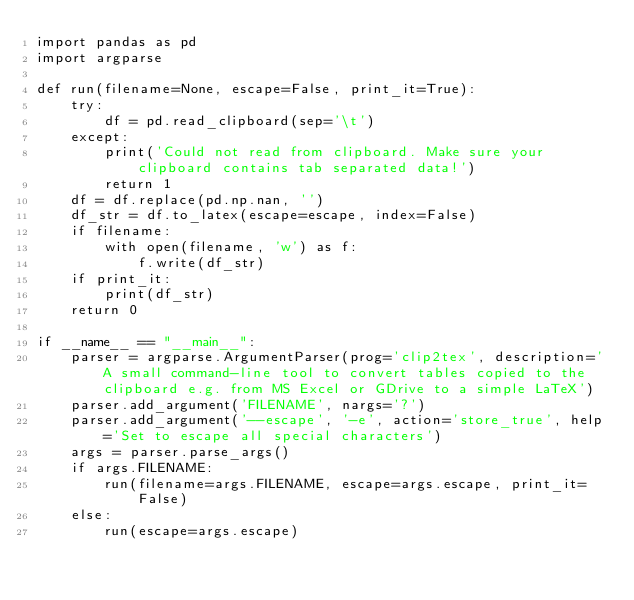Convert code to text. <code><loc_0><loc_0><loc_500><loc_500><_Python_>import pandas as pd
import argparse

def run(filename=None, escape=False, print_it=True):
    try:
        df = pd.read_clipboard(sep='\t')
    except:
        print('Could not read from clipboard. Make sure your clipboard contains tab separated data!')
        return 1
    df = df.replace(pd.np.nan, '')
    df_str = df.to_latex(escape=escape, index=False)
    if filename:
        with open(filename, 'w') as f:
            f.write(df_str)
    if print_it:
        print(df_str)
    return 0

if __name__ == "__main__":
    parser = argparse.ArgumentParser(prog='clip2tex', description='A small command-line tool to convert tables copied to the clipboard e.g. from MS Excel or GDrive to a simple LaTeX')
    parser.add_argument('FILENAME', nargs='?')
    parser.add_argument('--escape', '-e', action='store_true', help='Set to escape all special characters')
    args = parser.parse_args()
    if args.FILENAME:
        run(filename=args.FILENAME, escape=args.escape, print_it=False)
    else:
        run(escape=args.escape)

</code> 